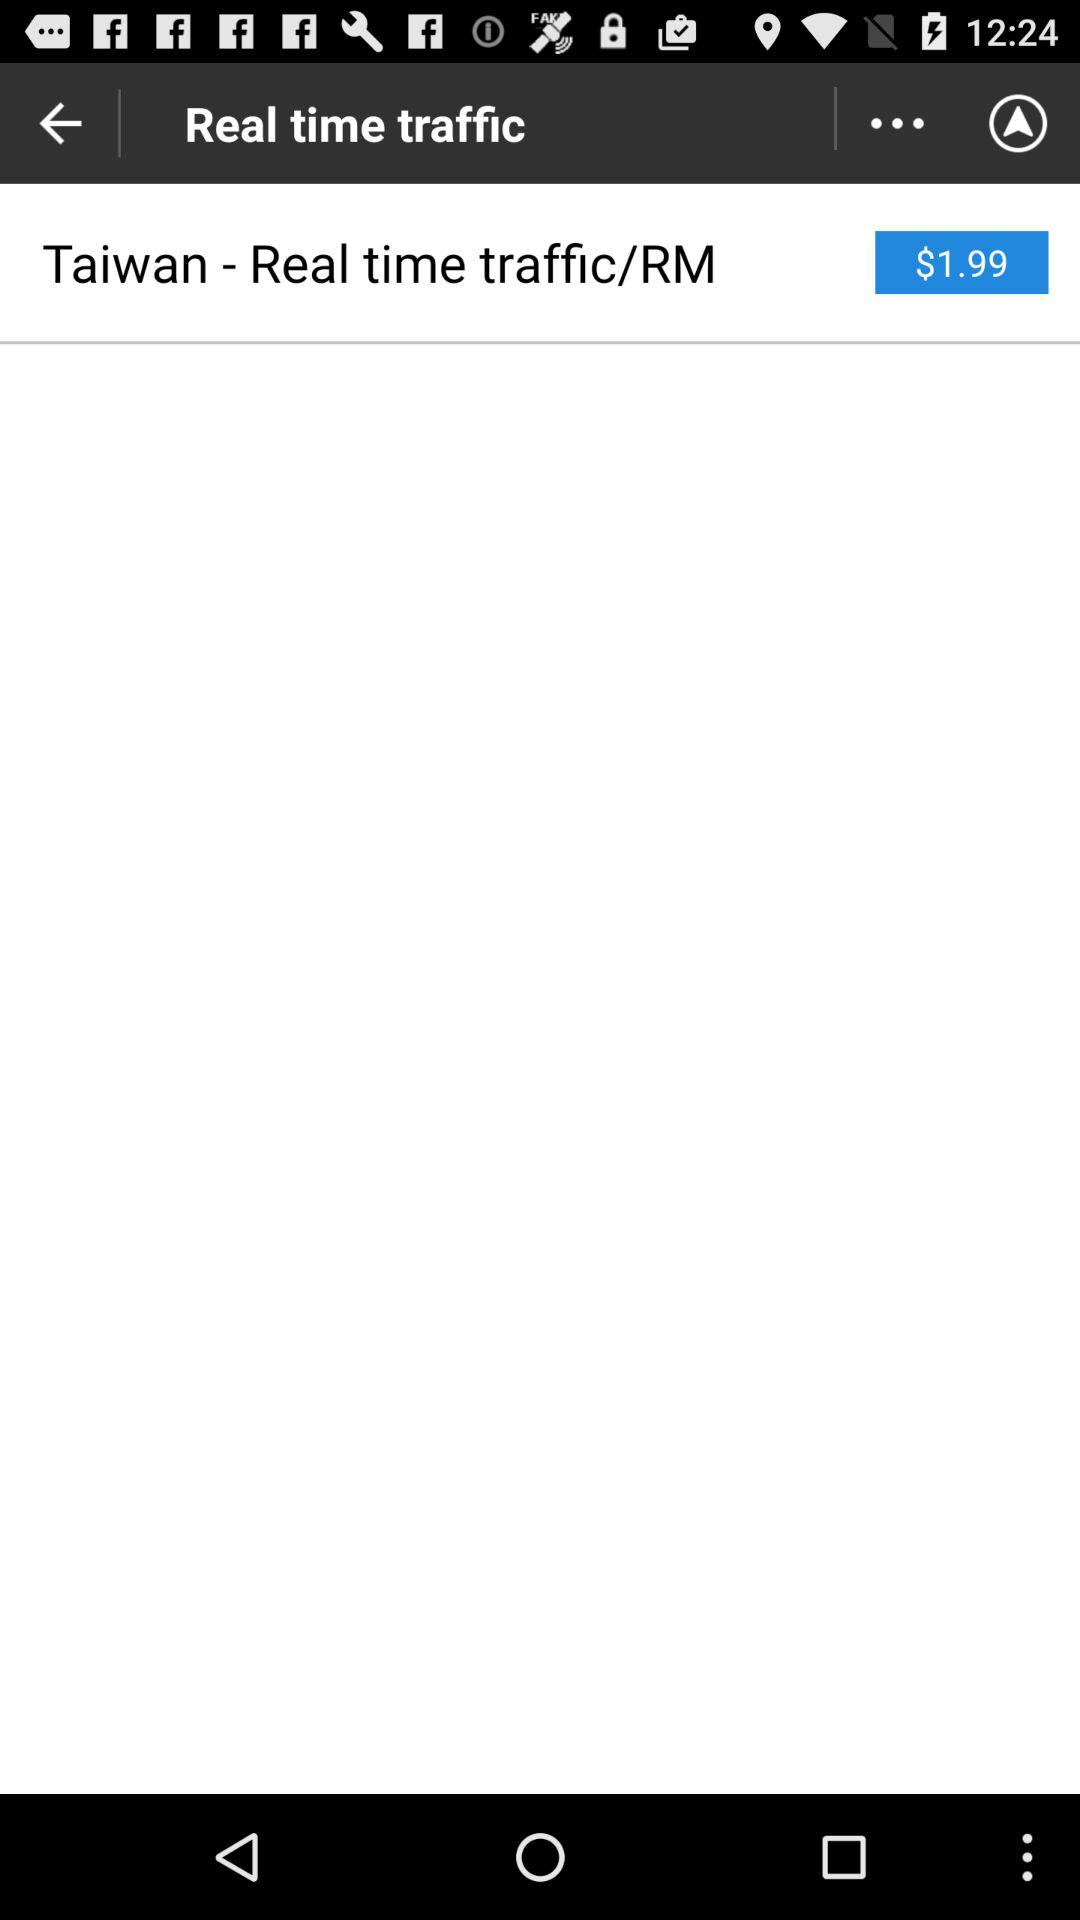What is the price for "Taiwan - Real time traffic/RM"? The price for "Taiwan - Real time traffic/RM" is $1.99. 